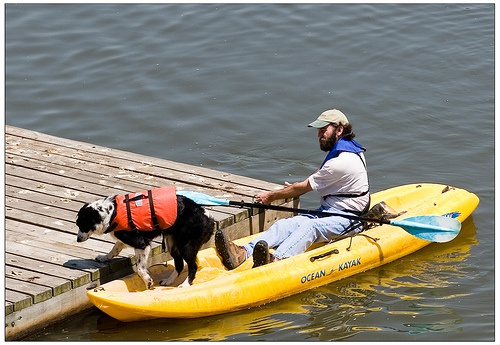Describe the objects in this image and their specific colors. I can see boat in white, khaki, gold, and orange tones, people in white, lavender, black, gray, and darkgray tones, and dog in white, black, salmon, and maroon tones in this image. 